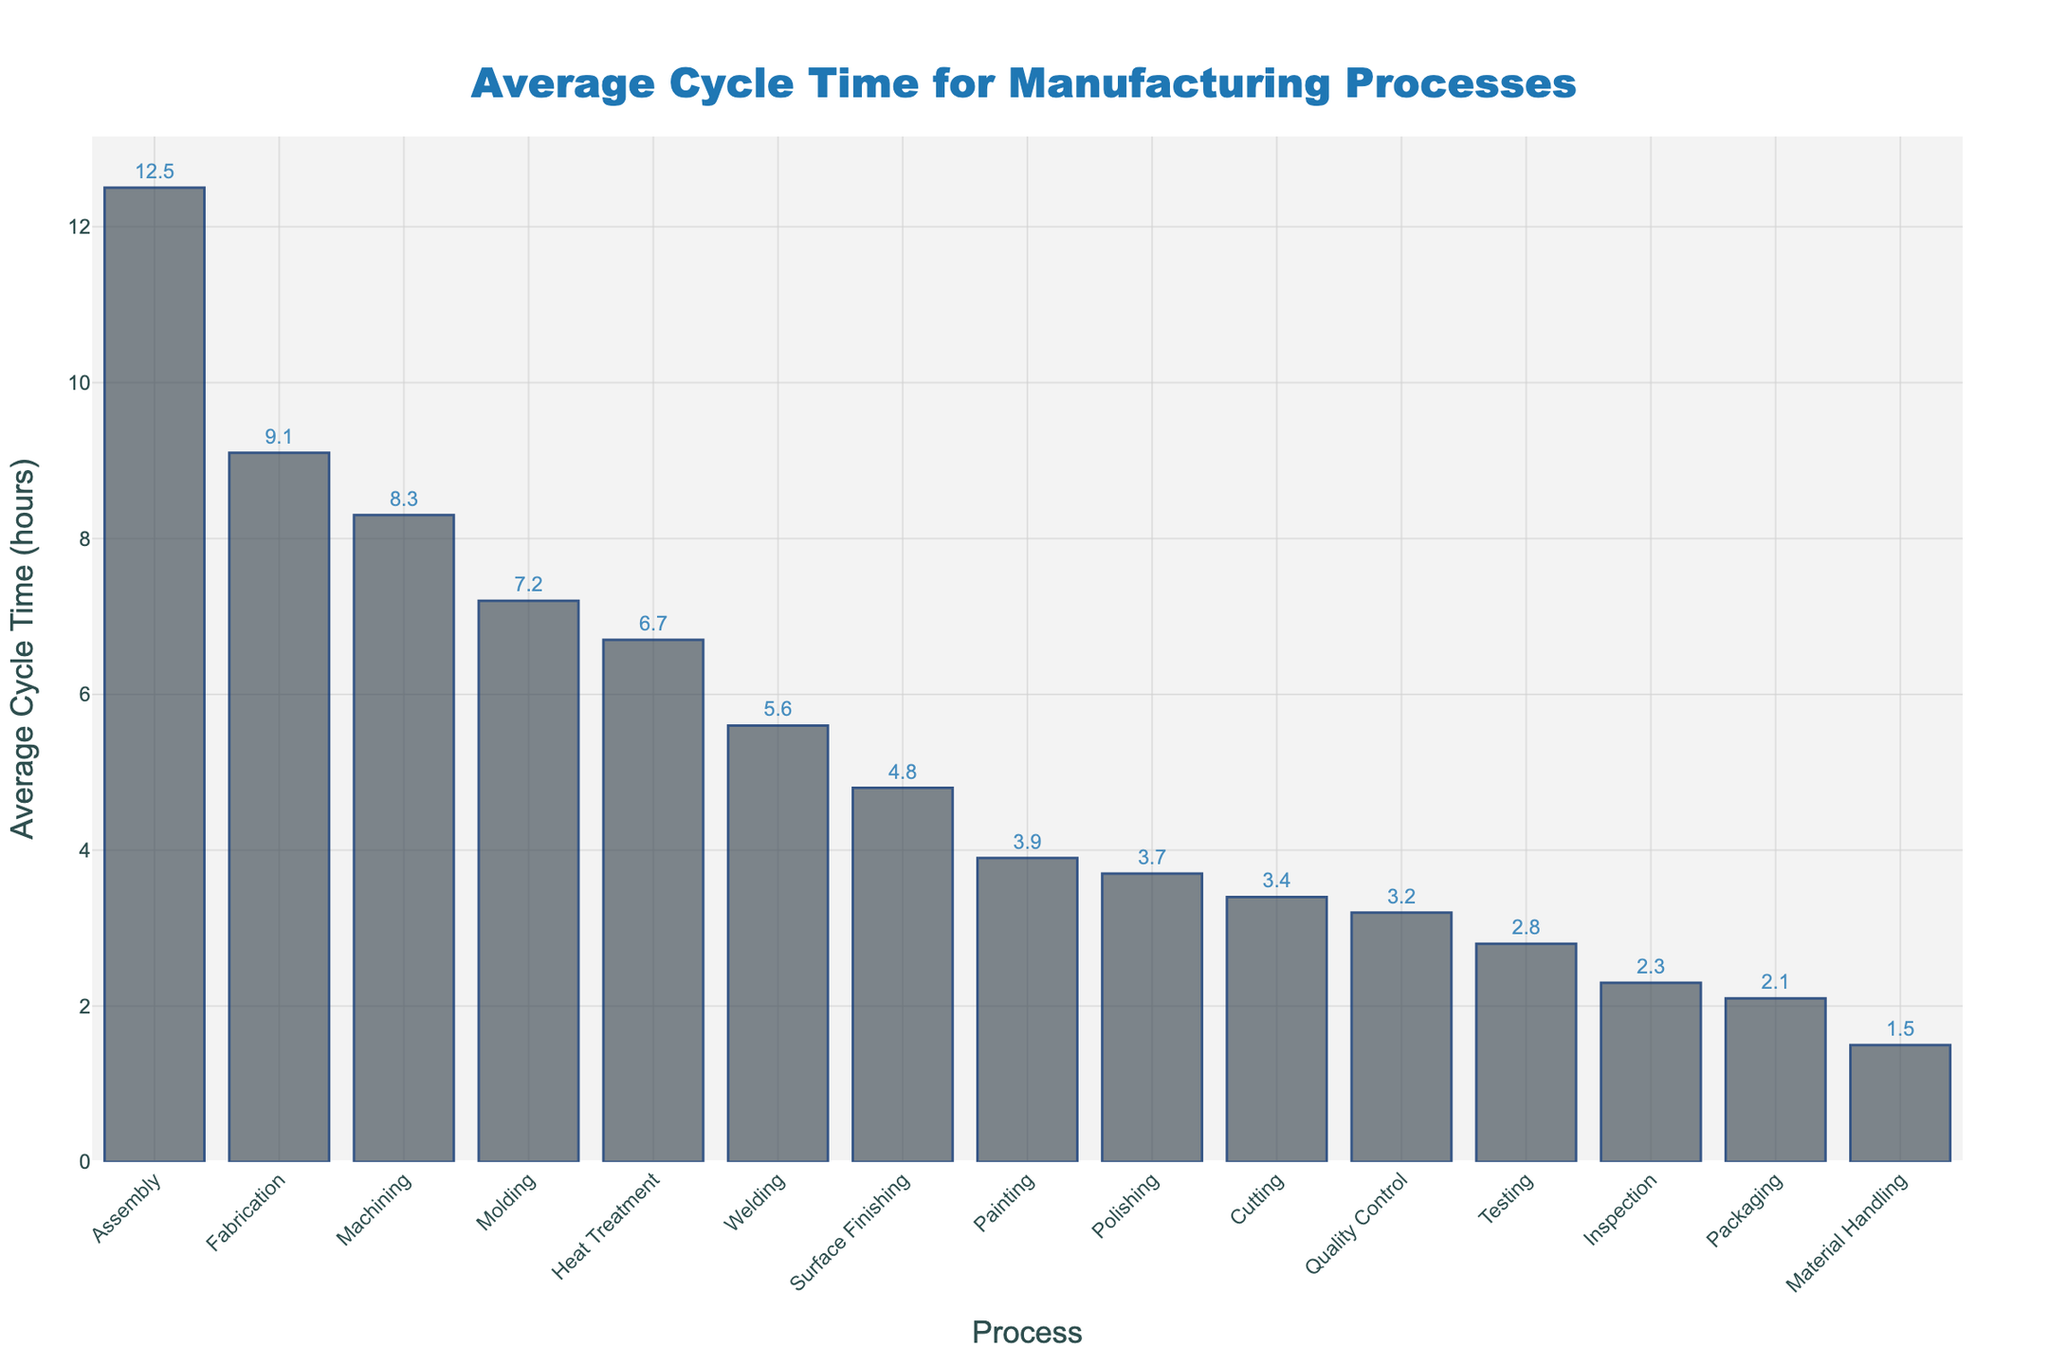What process has the longest average cycle time? Looking at the bar chart, the tallest bar represents the process with the longest average cycle time. In this case, "Assembly" has the longest bar.
Answer: Assembly Which process has the shortest average cycle time? The shortest bar indicates the process with the shortest average cycle time. In this case, "Material Handling" has the shortest bar.
Answer: Material Handling What is the difference in average cycle time between the Assembly and Machining processes? The average cycle time for Assembly is 12.5 hours and for Machining is 8.3 hours. The difference is calculated as 12.5 - 8.3.
Answer: 4.2 hours Are there any processes with an average cycle time less than 3 hours? If so, which ones? By observing the bars that extend up to 3 on the y-axis, "Packaging," "Material Handling," "Testing," and "Inspection" have an average cycle time less than 3 hours.
Answer: Packaging, Material Handling, Testing, Inspection How much longer is the average cycle time for the Fabrication process compared to the Painting process? The average cycle time for Fabrication is 9.1 hours and for Painting is 3.9 hours. The difference is calculated as 9.1 - 3.9.
Answer: 5.2 hours What is the total average cycle time for Quality Control, Heat Treatment, and Surface Finishing combined? Add the average cycle times: 3.2 hours (Quality Control) + 6.7 hours (Heat Treatment) + 4.8 hours (Surface Finishing). The total is calculated as 3.2 + 6.7 + 4.8.
Answer: 14.7 hours Which processes have an average cycle time between 5 and 10 hours? Bars that extend between 5 and 10 on the y-axis represent the processes "Machining," "Heat Treatment," "Welding," "Molding," "Fabrication," and "Cutting."
Answer: Machining, Heat Treatment, Welding, Molding, Cutting Is the Heat Treatment process faster than the Welding process? Compare the heights of the bars for "Heat Treatment" and "Welding." "Heat Treatment" (6.7 hours) is not faster than "Welding" (5.6 hours).
Answer: No What is the average cycle time of all processes rounded to one decimal place? Sum all the average cycle times: (12.5 + 8.3 + 3.2 + 6.7 + 2.1 + 4.8 + 1.5 + 5.6 + 3.9 + 2.8 + 7.2 + 3.4 + 9.1 + 2.3 + 3.7) = 77.1 hours. There are 15 processes, so the average is 77.1 / 15.
Answer: 5.1 hours 